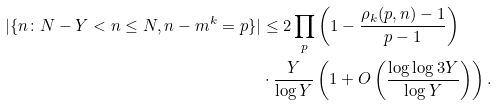<formula> <loc_0><loc_0><loc_500><loc_500>| \{ n \colon N - Y < n \leq N , n - m ^ { k } = p \} | & \leq 2 \prod _ { p } \left ( 1 - \frac { \rho _ { k } ( p , n ) - 1 } { p - 1 } \right ) \\ & \cdot \frac { Y } { \log Y } \left ( 1 + O \left ( \frac { \log \log 3 Y } { \log Y } \right ) \right ) .</formula> 